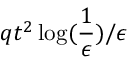Convert formula to latex. <formula><loc_0><loc_0><loc_500><loc_500>q t ^ { 2 } \log ( \frac { 1 } { \epsilon } ) / \epsilon</formula> 